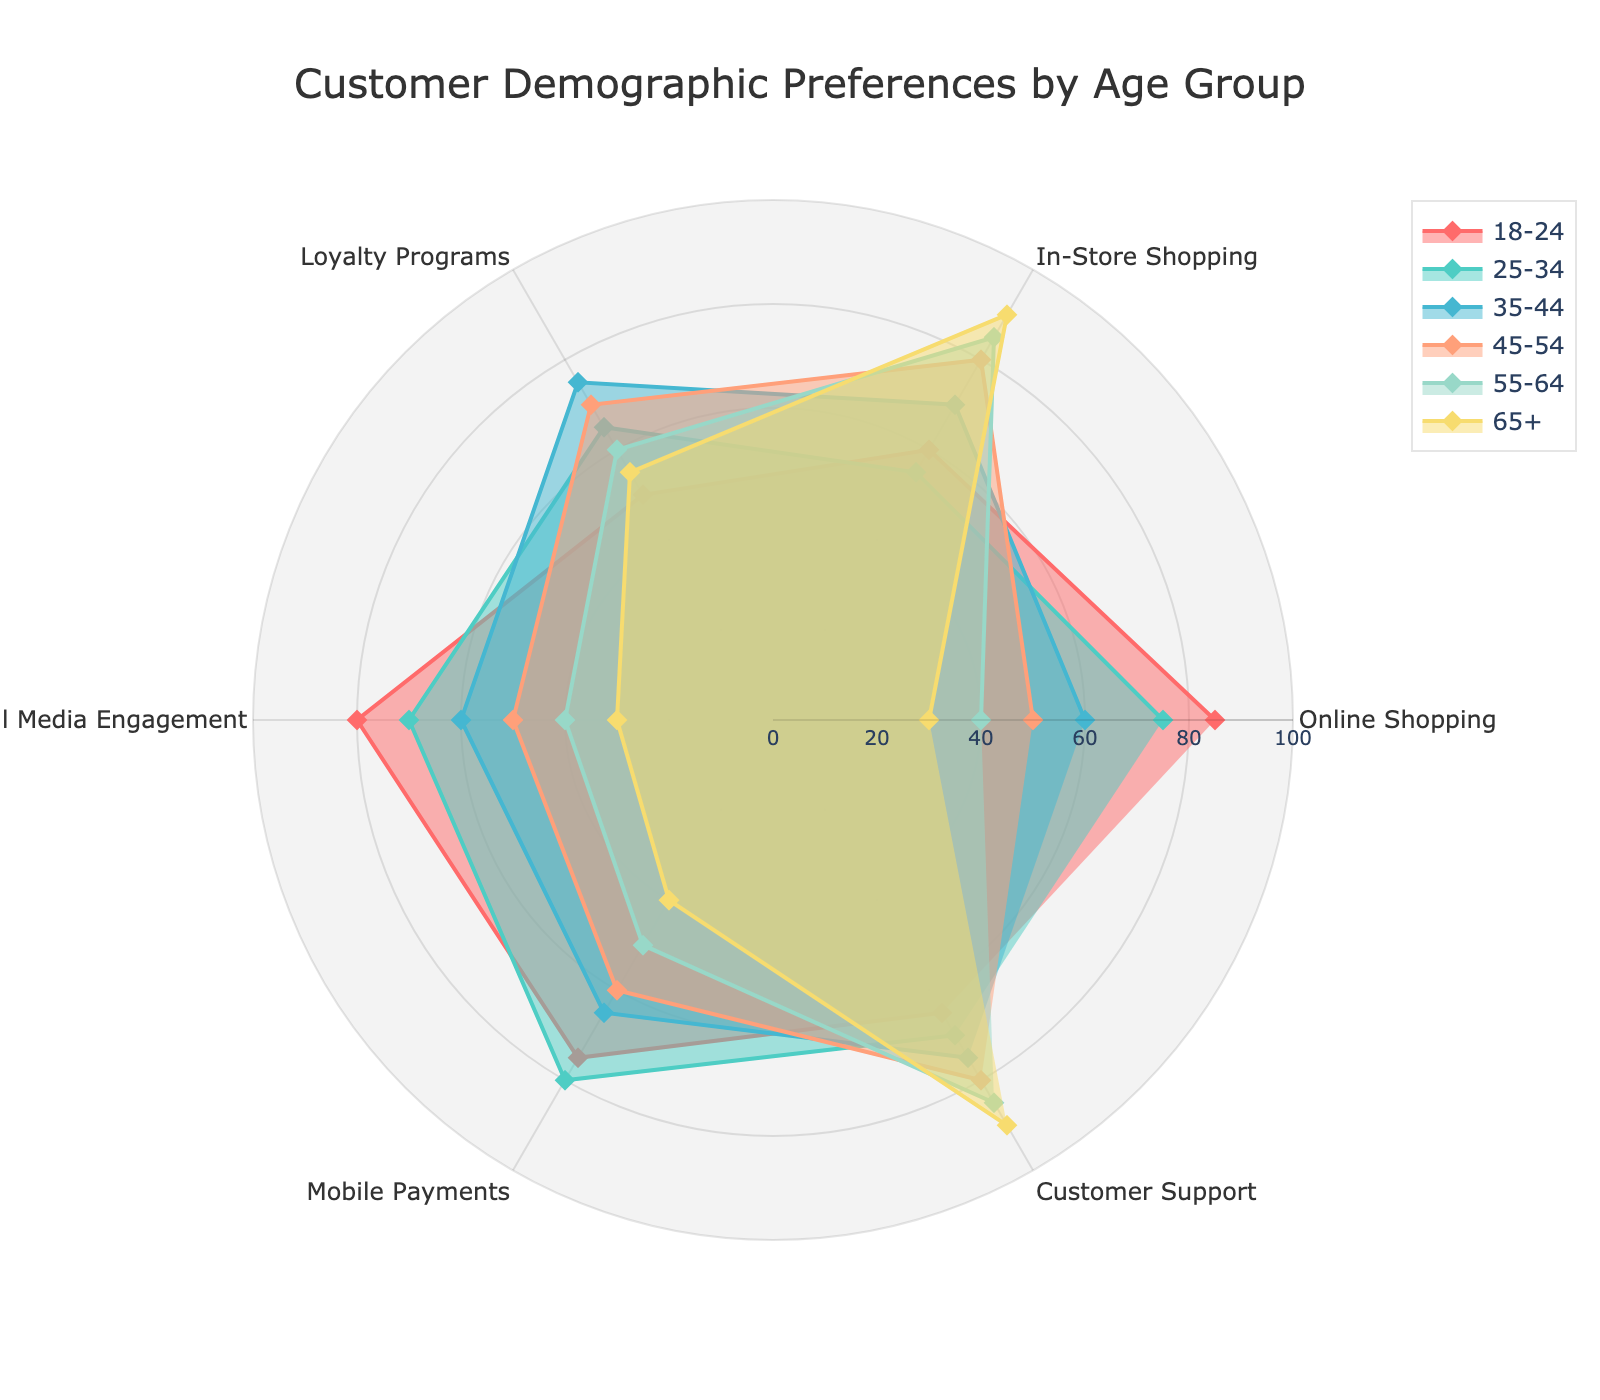What is the age group with the highest preference for Online Shopping? The radar chart shows that the 18-24 age group has the highest score for Online Shopping, reaching 85. This is the peak on the radar chart for the Online Shopping category.
Answer: 18-24 Which age group has the lowest preference for Mobile Payments? Referencing the radar chart, the age group 65+ has the lowest reported preference for Mobile Payments with a score of 40.
Answer: 65+ Among the given age groups, which group has the highest engagement in Social Media? By examining the radar chart, the 18-24 age group stands out with the highest Social Media Engagement at a score of 80.
Answer: 18-24 Compare the preferences for Customer Support between the 45-54 and 65+ age groups. Which one is higher? The radar chart indicates that the preference for Customer Support in the 45-54 age group is 80, while the 65+ age group has a slightly higher preference at 90.
Answer: 65+ Which age group shows the lowest engagement in In-Store Shopping? The radar chart displays that the 18-24 age group has the lowest engagement in In-Store Shopping with a score of 60.
Answer: 18-24 What is the average preference for Loyalty Programs across the 25-34 and 35-44 age groups? The average is calculated by adding the Loyalty Programs scores of these two age groups and then dividing by 2: (65 + 75) / 2 = 70.
Answer: 70 Identify the most consistent preference (least variance) between age groups for any one category. Customer Support scores range from 65 to 90 across age groups, consistently high and tightly clustered with a least variance compared to other categories.
Answer: Customer Support For the 55-64 age group, what is the difference between their preference for In-Store Shopping and Mobile Payments? The preference scores are 85 for In-Store Shopping and 50 for Mobile Payments, making the difference 85 - 50 = 35.
Answer: 35 How does the 35-44 age group’s preference for Social Media Engagement compare to that for Loyalty Programs? The radar chart shows that the 35-44 age group prefers Loyalty Programs (75) over Social Media Engagement (60).
Answer: Loyalty Programs higher Which category shows a decreasing trend in preference as the age increases? Observing all categories, Online Shopping decreases consistently as the age increases from 18-24 to 65+.
Answer: Online Shopping 